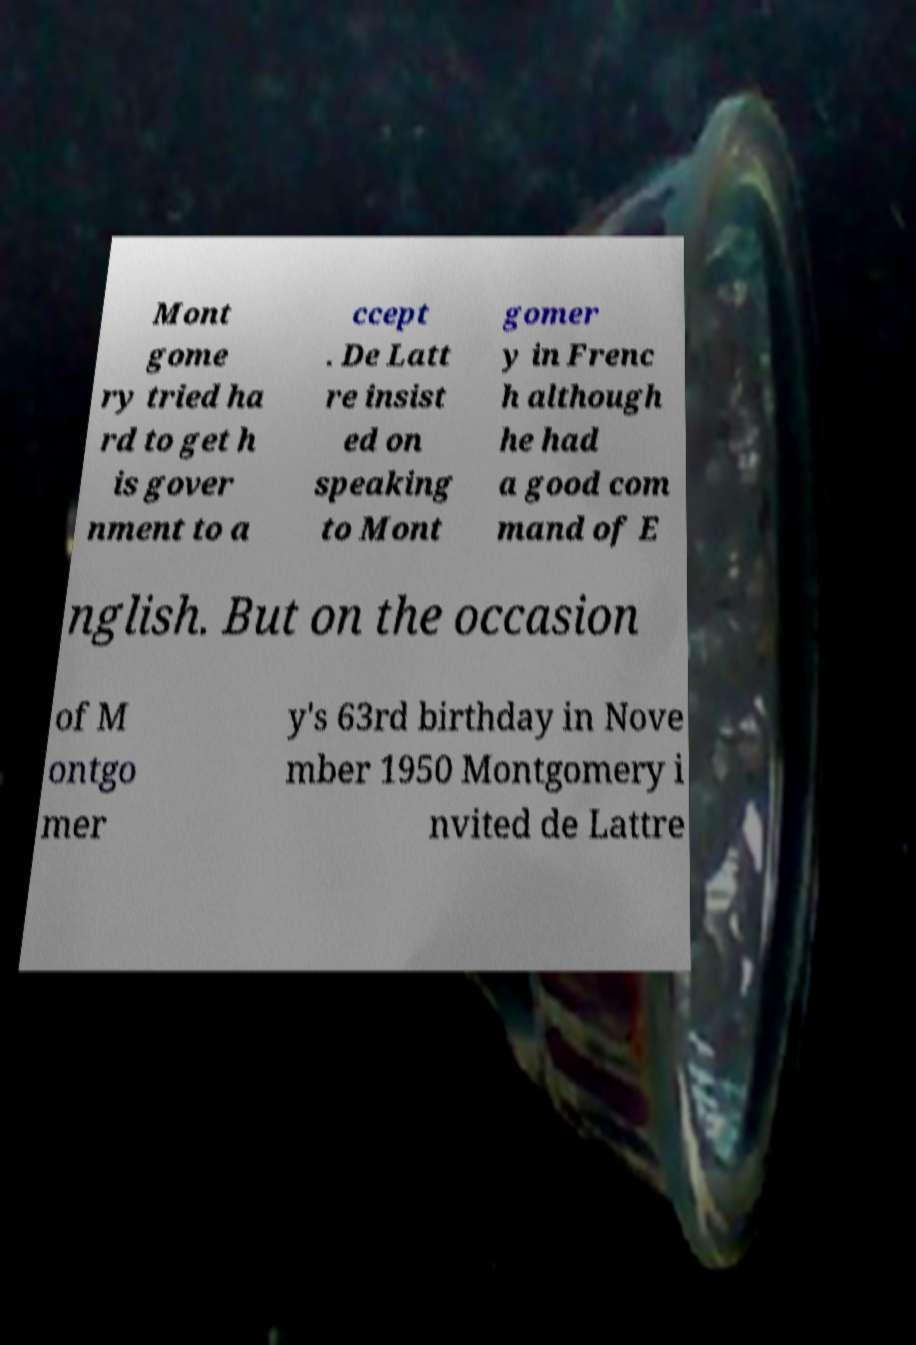There's text embedded in this image that I need extracted. Can you transcribe it verbatim? Mont gome ry tried ha rd to get h is gover nment to a ccept . De Latt re insist ed on speaking to Mont gomer y in Frenc h although he had a good com mand of E nglish. But on the occasion of M ontgo mer y's 63rd birthday in Nove mber 1950 Montgomery i nvited de Lattre 